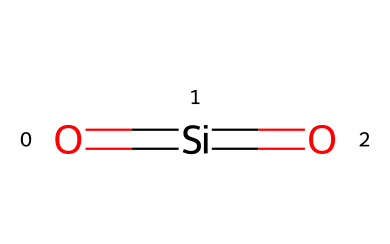What is the main chemical element in nanosilica? The chemical structure contains silicon (Si) at its core, identified by the notation O=[Si]=O, where silicon is the central atom bonded to oxygen atoms.
Answer: silicon How many oxygen atoms are present in the molecular structure? The rendered chemical structure shows two oxygen atoms (O) bonded to the central silicon atom (Si), thus indicating there are 2 oxygens present.
Answer: 2 What type of bonding is present between the silicon and oxygen atoms? The structure indicates double bonding (denoted by the "=" between Si and O), which means that each silicon atom is bonded to the oxygen atoms via double covalent bonds.
Answer: double bond What potential effect does the nanosilica have on cement strength? Nanosilica enhances the cement strength primarily due to its high surface area and reactivity, which contribute to improved bonding and microstructural properties in the cement matrix.
Answer: enhances strength How does the arrangement of nanosilica particles affect their function in cement? The arrangement and distribution of nanosilica particles in the cement matrix play a crucial role in optimizing their performance by filling voids, reducing porosity, and improving the overall mechanical properties.
Answer: fills voids What is the typical application of nanosilica in civil engineering? Nanosilica is typically used as an additive in concrete and cement formulations to improve strength and durability.
Answer: concrete additive What size range classifies nanosilica as a nanomaterial? Nanosilica is classified as a nanomaterial if it has primary particle sizes in the range of 1 to 100 nanometers.
Answer: 1 to 100 nanometers 